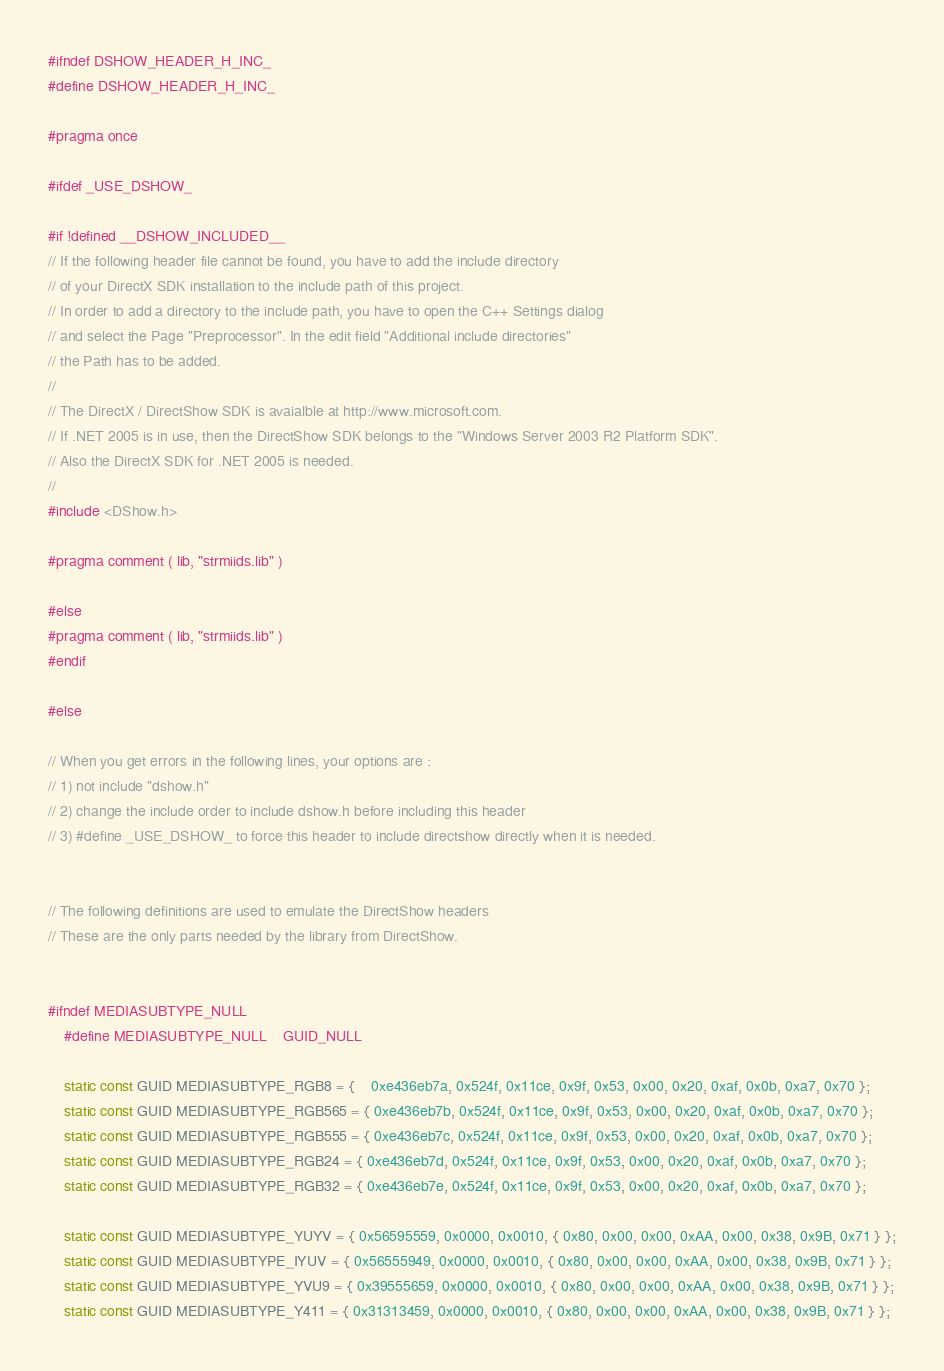Convert code to text. <code><loc_0><loc_0><loc_500><loc_500><_C_>
#ifndef DSHOW_HEADER_H_INC_
#define DSHOW_HEADER_H_INC_

#pragma once

#ifdef _USE_DSHOW_

#if !defined __DSHOW_INCLUDED__
// If the following header file cannot be found, you have to add the include directory
// of your DirectX SDK installation to the include path of this project.
// In order to add a directory to the include path, you have to open the C++ Settings dialog
// and select the Page "Preprocessor". In the edit field "Additional include directories"
// the Path has to be added.
// 
// The DirectX / DirectShow SDK is avaialble at http://www.microsoft.com.
// If .NET 2005 is in use, then the DirectShow SDK belongs to the "Windows Server 2003 R2 Platform SDK".
// Also the DirectX SDK for .NET 2005 is needed.
//
#include <DShow.h>

#pragma comment ( lib, "strmiids.lib" )

#else
#pragma comment ( lib, "strmiids.lib" )
#endif

#else

// When you get errors in the following lines, your options are :
// 1) not include "dshow.h"
// 2) change the include order to include dshow.h before including this header
// 3) #define _USE_DSHOW_ to force this header to include directshow directly when it is needed.


// The following definitions are used to emulate the DirectShow headers
// These are the only parts needed by the library from DirectShow.


#ifndef MEDIASUBTYPE_NULL
	#define MEDIASUBTYPE_NULL    GUID_NULL

	static const GUID MEDIASUBTYPE_RGB8 = {	0xe436eb7a, 0x524f, 0x11ce, 0x9f, 0x53, 0x00, 0x20, 0xaf, 0x0b, 0xa7, 0x70 };
	static const GUID MEDIASUBTYPE_RGB565 = { 0xe436eb7b, 0x524f, 0x11ce, 0x9f, 0x53, 0x00, 0x20, 0xaf, 0x0b, 0xa7, 0x70 };
	static const GUID MEDIASUBTYPE_RGB555 = { 0xe436eb7c, 0x524f, 0x11ce, 0x9f, 0x53, 0x00, 0x20, 0xaf, 0x0b, 0xa7, 0x70 };
	static const GUID MEDIASUBTYPE_RGB24 = { 0xe436eb7d, 0x524f, 0x11ce, 0x9f, 0x53, 0x00, 0x20, 0xaf, 0x0b, 0xa7, 0x70 };
	static const GUID MEDIASUBTYPE_RGB32 = { 0xe436eb7e, 0x524f, 0x11ce, 0x9f, 0x53, 0x00, 0x20, 0xaf, 0x0b, 0xa7, 0x70 };

	static const GUID MEDIASUBTYPE_YUYV = { 0x56595559, 0x0000, 0x0010, { 0x80, 0x00, 0x00, 0xAA, 0x00, 0x38, 0x9B, 0x71 } };
	static const GUID MEDIASUBTYPE_IYUV = { 0x56555949, 0x0000, 0x0010, { 0x80, 0x00, 0x00, 0xAA, 0x00, 0x38, 0x9B, 0x71 } };
	static const GUID MEDIASUBTYPE_YVU9 = { 0x39555659, 0x0000, 0x0010, { 0x80, 0x00, 0x00, 0xAA, 0x00, 0x38, 0x9B, 0x71 } };
	static const GUID MEDIASUBTYPE_Y411 = { 0x31313459, 0x0000, 0x0010, { 0x80, 0x00, 0x00, 0xAA, 0x00, 0x38, 0x9B, 0x71 } };</code> 